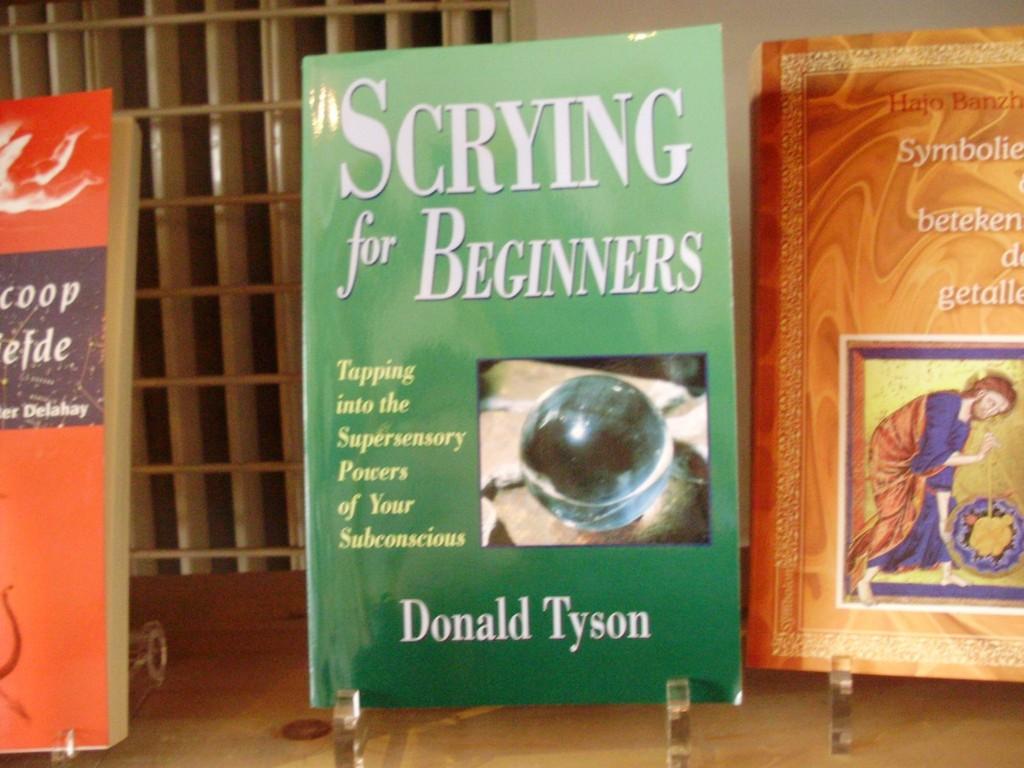Who wrote the book with the green cover?
Provide a succinct answer. Donald tyson. What is the title of the green book?
Provide a short and direct response. Scrying for beginners. 